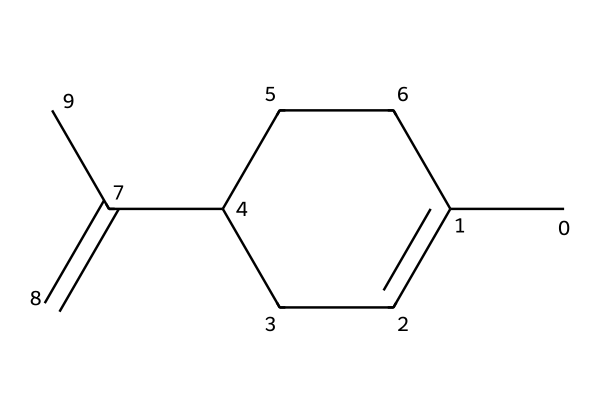What is the molecular formula of limonene? To determine the molecular formula, count the number of carbon (C) and hydrogen (H) atoms in the structure. There are 10 carbon atoms and 16 hydrogen atoms. Therefore, the molecular formula is C10H16.
Answer: C10H16 How many rings are present in this structure? The given structure depicts a cycloalkane, which is characterized by a ring. In this case, the structure shows only one ring.
Answer: one What type of compound is limonene? Limonene is classified as a terpene, which is a category of compounds derived from plant sources and often contains isoprene units. The structure displays the traits of a terpene due to its cyclic nature and branching.
Answer: terpene Does limonene contain any double bonds? Upon examining the structure, it is evident that there is at least one double bond in the molecule indicated by the C(=C) part of the structure.
Answer: yes What functional groups are present in limonene? The primary functional group in limonene is the alkene group due to the presence of the double bond. There are no other specific functional groups in the structure aside from this.
Answer: alkene How many carbon atoms are part of the cyclic structure? By analyzing the ring portion of the structure, it can be seen that 5 carbon atoms are directly involved in forming the cyclic structure.
Answer: five 